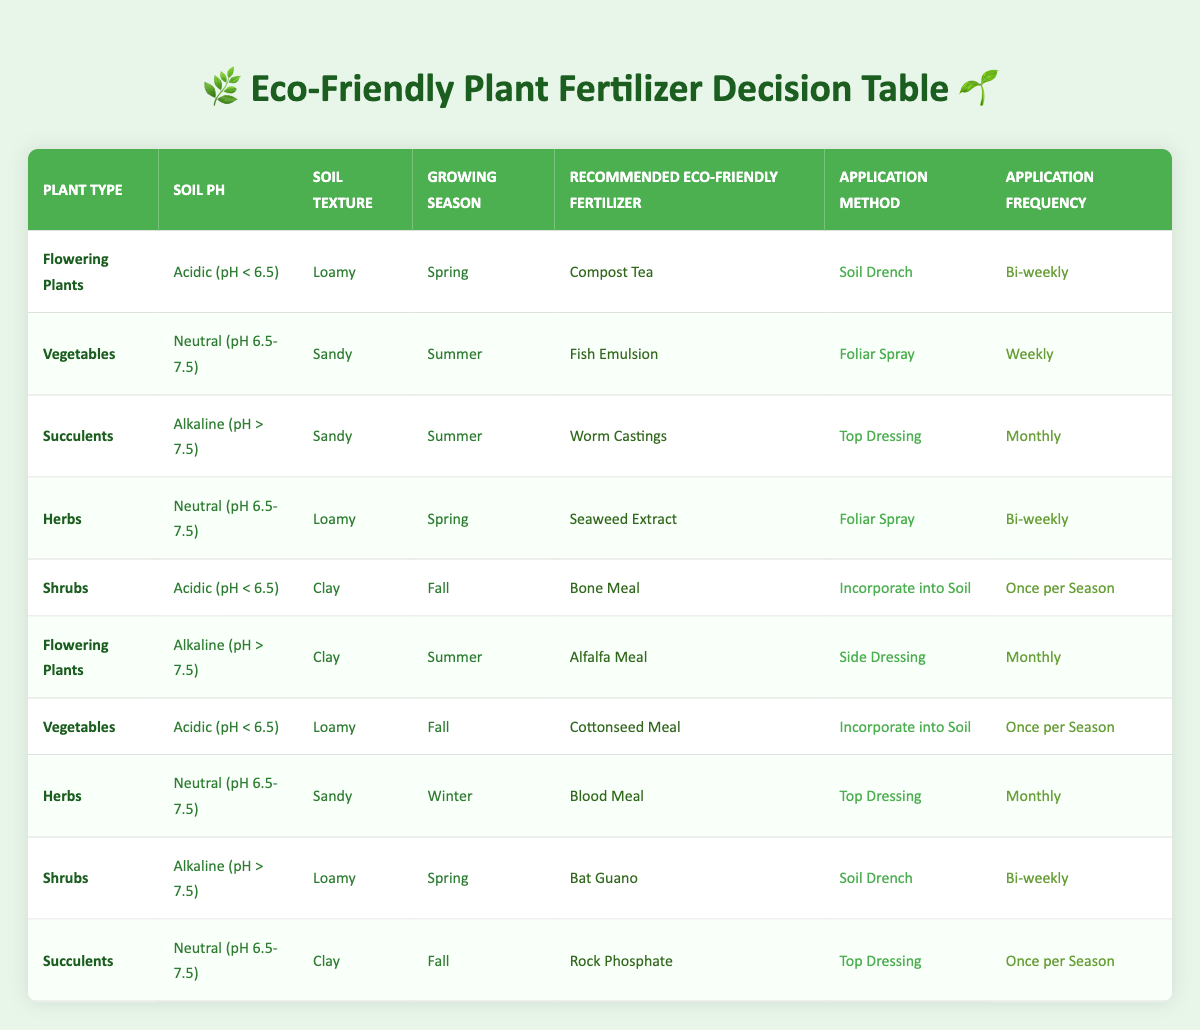What is the recommended eco-friendly fertilizer for flowering plants in neutral soil type? The table indicates that for flowering plants, there is no entry under neutral soil pH. Hence, the specific recommendations only apply to acidic or alkaline conditions.
Answer: None What is the application method for vegetables in acidic soil during fall? The table shows the recommended fertilizer for vegetables in acidic soil during fall is Cottonseed Meal, and the application method is to incorporate it into the soil.
Answer: Incorporate into Soil How often should seaweed extract be applied to herbs in spring? The table states that herbs in spring should receive Seaweed Extract bi-weekly.
Answer: Bi-weekly Are succulents recommended to be fertilized every week in the summer? The table indicates that succulents in alkaline soil during summer should be fertilized with Worm Castings monthly, not weekly.
Answer: No Which type of fertilizer is recommended for shrubs in acidic soil during fall? The recommended eco-friendly fertilizer for shrubs in acidic soil during fall is Bone Meal, according to the table.
Answer: Bone Meal How many different application methods are listed in the table? The table lists five different application methods: Top Dressing, Soil Drench, Foliar Spray, Side Dressing, and Incorporate into Soil. The count is five.
Answer: Five What is the cumulative frequency of application for flowering plants in both acidic spring and alkaline summer soils? Flowering plants in acidic spring are fertilized bi-weekly, while in alkaline summer, they are fertilized monthly. Converting bi-weekly means every two weeks (26 times a year), and monthly means 12 times a year. Therefore, the cumulative frequency is 26 + 12 = 38 times a year.
Answer: 38 Is fish emulsion recommended in summer for sandy soil with neutral pH? The table shows that Fish Emulsion is indeed the recommended fertilizer for vegetables in sandy soil with neutral pH during summer.
Answer: Yes What is the difference in application frequency between bat guano for shrubs in spring and blood meal for herbs in winter? Bat Guano for shrubs in alkaline soil during spring has a bi-weekly application frequency, while blood meal for herbs in winter has a monthly application frequency (which means it is applied once every four weeks). The difference is bi-weekly (26 times) minus monthly (12 times), yielding 14.
Answer: 14 